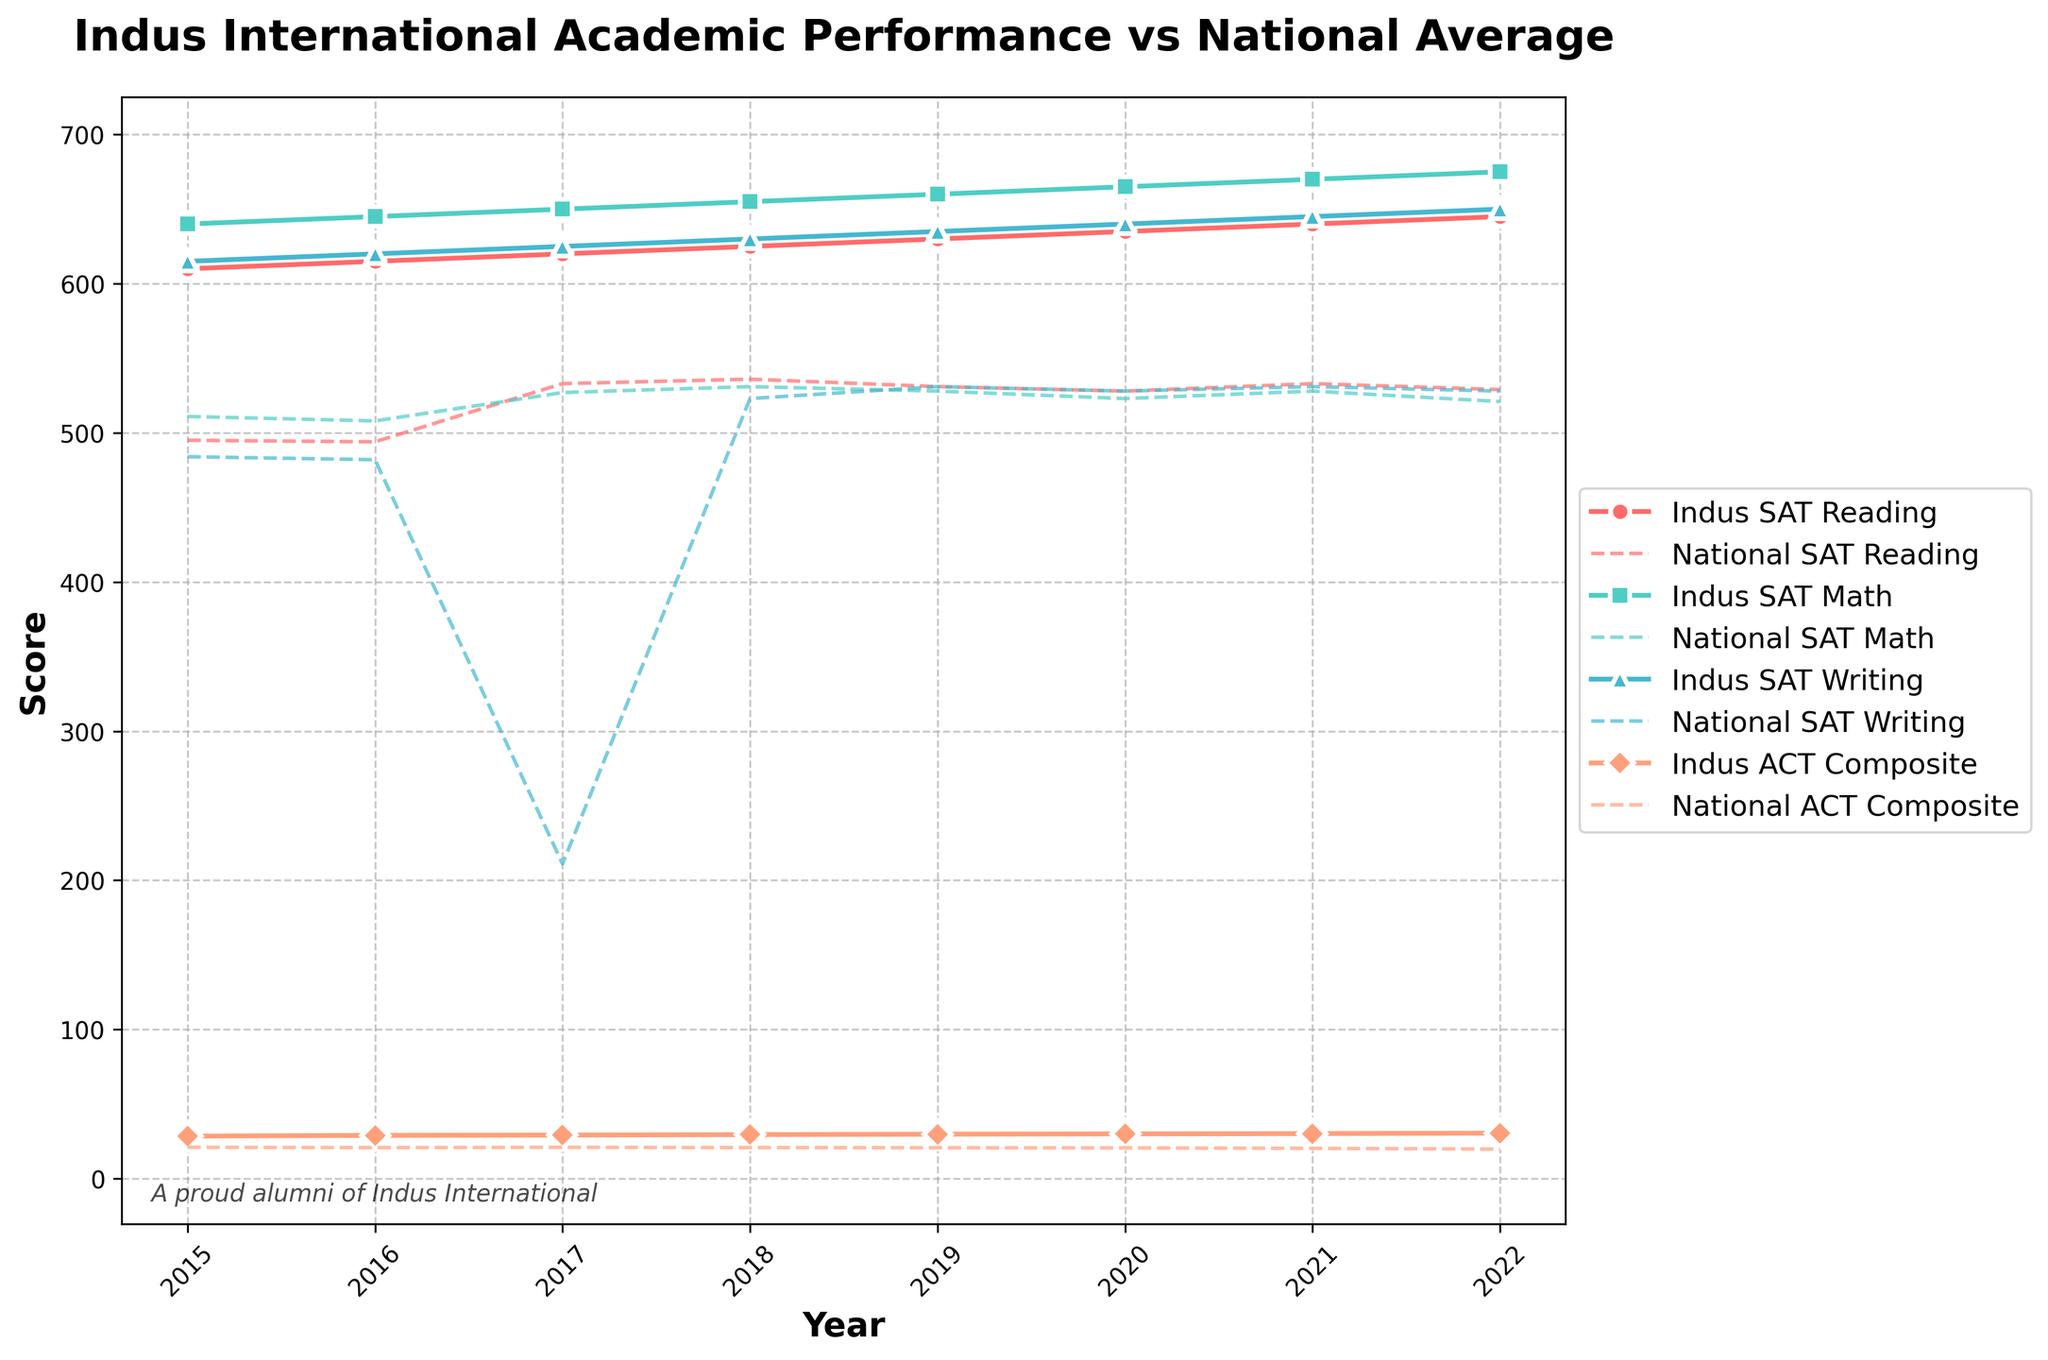What's the difference in SAT Math scores between Indus International and the national average in 2022? To find the difference in SAT Math scores between Indus International students and the national average in 2022, subtract the national score from the Indus score: 675 - 521 = 154
Answer: 154 How much did the Indus International ACT Composite score improve from 2015 to 2022? Subtract the ACT Composite score of 2015 from that of 2022: 30.5 - 28.5 = 2.0.
Answer: 2.0 In which year did Indus International students have the highest SAT Reading score, and what was the score? Look for the highest point on the SAT Reading (solid red line) plot. The highest SAT Reading score is in 2022, with a score of 645.
Answer: 2022, 645 Compare the trend of the SAT Writing scores for Indus International students and the national average from 2015 to 2022. Indus International students' SAT Writing scores steadily increased from 615 in 2015 to 650 in 2022. The national average initially dropped from 484 in 2015 to 211 in 2017 and then varied slightly, ending at 528 in 2022.
Answer: Indus scores increased; national average varied, ending higher than 2015 What's the average Indus International SAT Math score over the years presented? Add all the SAT Math scores of Indus International and divide by the number of years: (640 + 645 + 650 + 655 + 660 + 665 + 670 + 675) / 8 = 655.
Answer: 655 How do the 2020 average SAT Reading scores at Indus International compare to the national average? In 2020, Indus International's SAT Reading score was 635, while the national average was 528. Comparing both, Indus' score is higher by 635 - 528 = 107.
Answer: 107 higher What general pattern do you observe in the ACT Composite scores for both Indus International and the national averages over the years? The Indus International ACT Composite scores show a steadily increasing trend from 28.5 in 2015 to 30.5 in 2022. The national ACT Composite scores, on the other hand, show a slight, consistent decrease from 21.0 in 2015 to 19.8 in 2022.
Answer: Indus increases, national decreases Do Indus International students consistently outperform the national average in SAT Math? Yes, in every year from 2015 to 2022, Indus International SAT Math scores are higher than the respective national averages, as visualized by the solid green line (Indus) being consistently above the dashed green line (national).
Answer: Yes 